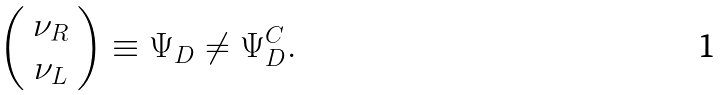Convert formula to latex. <formula><loc_0><loc_0><loc_500><loc_500>\left ( \begin{array} { c } \nu _ { R } \\ \nu _ { L } \end{array} \right ) \equiv \Psi _ { D } \neq \Psi _ { D } ^ { C } .</formula> 